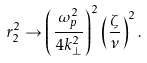<formula> <loc_0><loc_0><loc_500><loc_500>r _ { 2 } ^ { 2 } \rightarrow \left ( \frac { \omega _ { p } ^ { 2 } } { 4 k _ { \perp } ^ { 2 } } \right ) ^ { 2 } \left ( \frac { \zeta } { \nu } \right ) ^ { 2 } .</formula> 